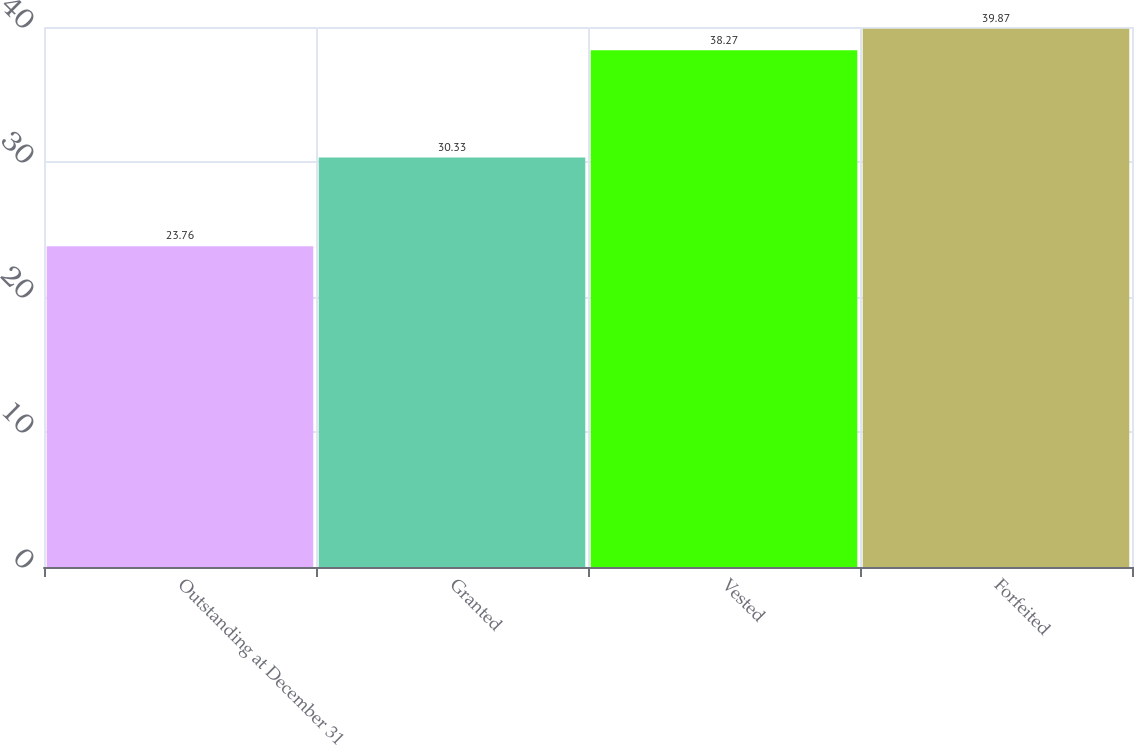<chart> <loc_0><loc_0><loc_500><loc_500><bar_chart><fcel>Outstanding at December 31<fcel>Granted<fcel>Vested<fcel>Forfeited<nl><fcel>23.76<fcel>30.33<fcel>38.27<fcel>39.87<nl></chart> 